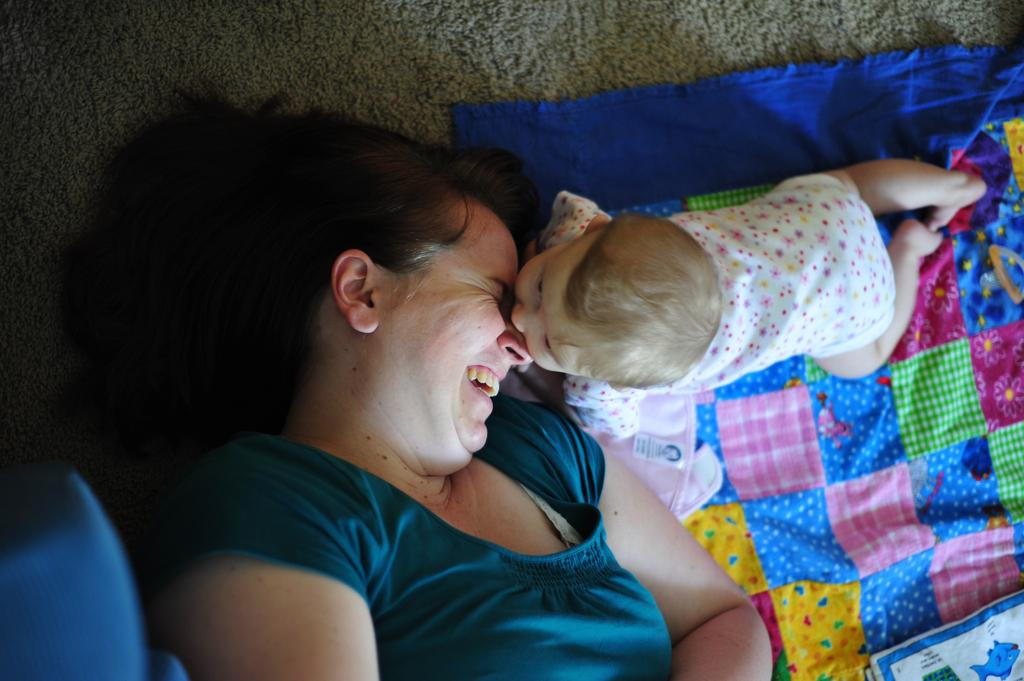What is the position of the woman in the image? The woman is lying on the floor. What is the kid doing in the image? The kid is crawling on a cloth. Where is the cloth located in relation to the woman? The cloth is beside the woman. What type of idea can be seen coming out of the hole in the image? There is no hole or idea present in the image. What kind of bike is visible in the image? There is no bike present in the image. 